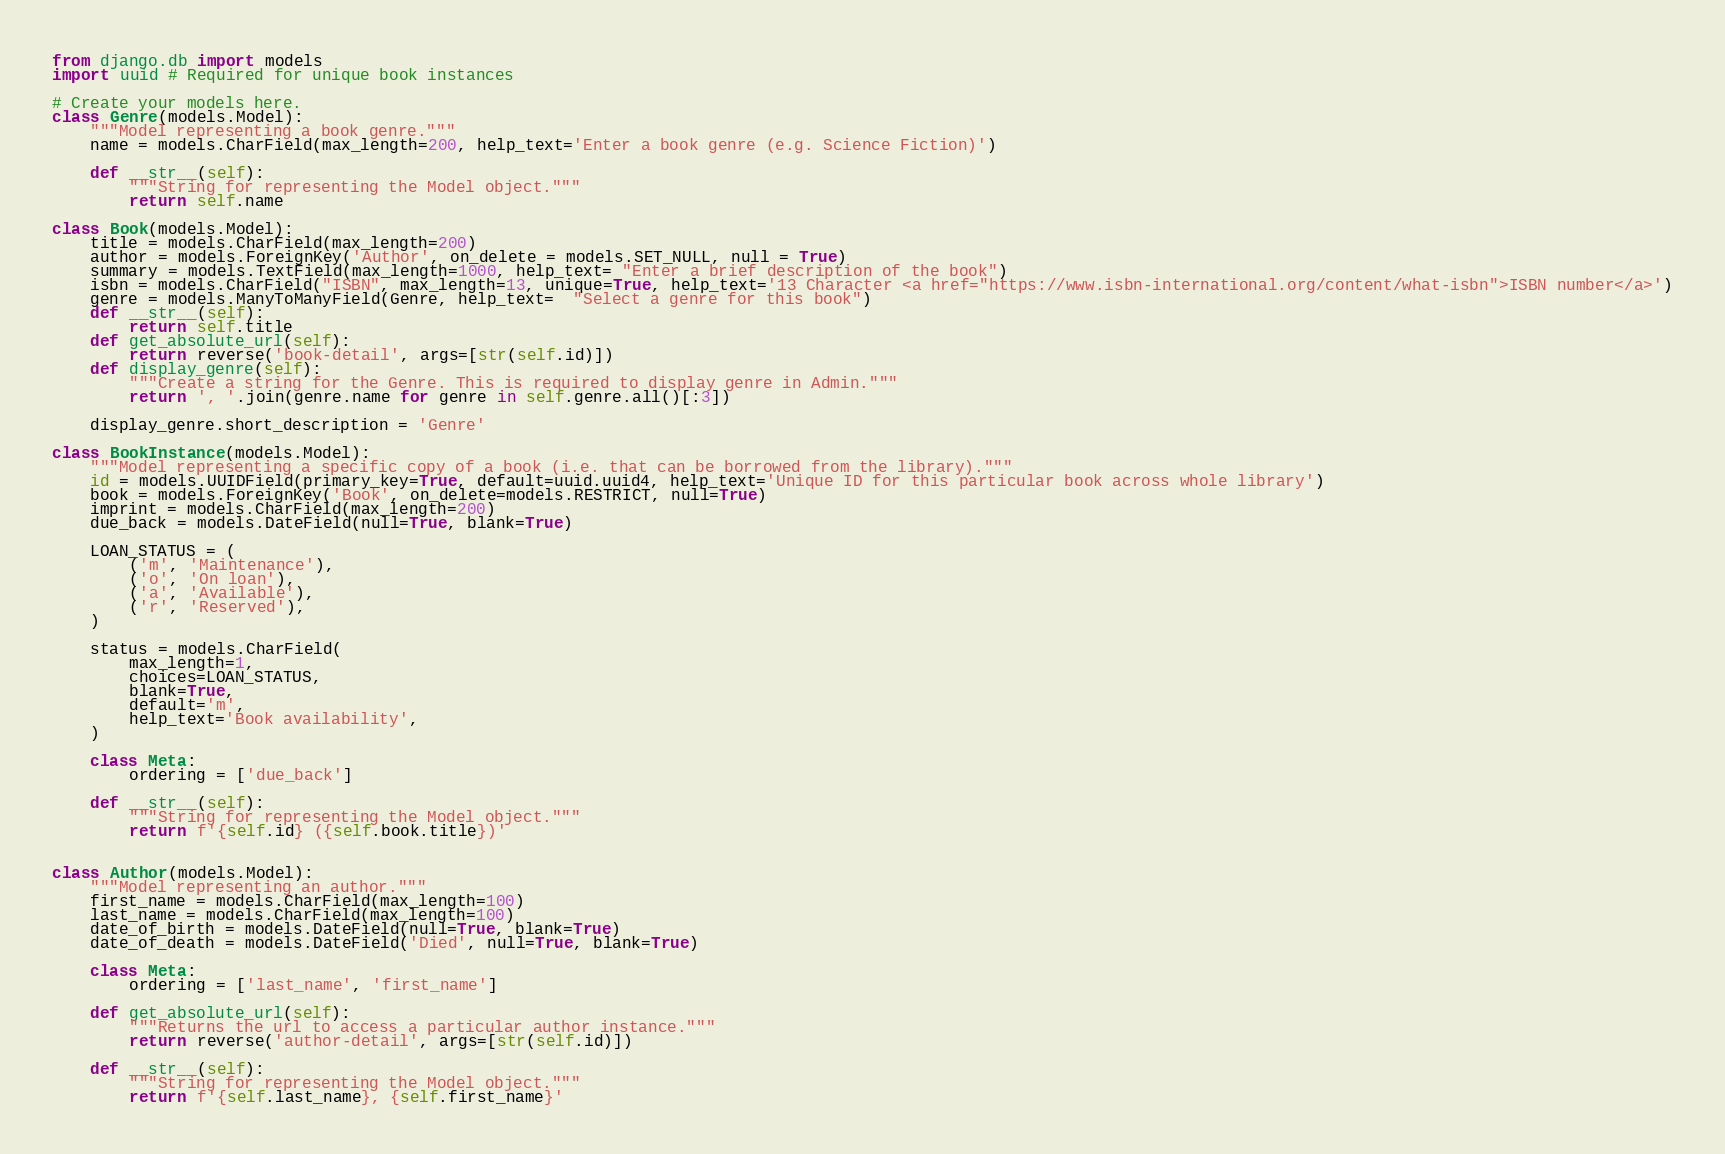<code> <loc_0><loc_0><loc_500><loc_500><_Python_>from django.db import models
import uuid # Required for unique book instances

# Create your models here.
class Genre(models.Model):
    """Model representing a book genre."""
    name = models.CharField(max_length=200, help_text='Enter a book genre (e.g. Science Fiction)')

    def __str__(self):
        """String for representing the Model object."""
        return self.name

class Book(models.Model):
    title = models.CharField(max_length=200)
    author = models.ForeignKey('Author', on_delete = models.SET_NULL, null = True)
    summary = models.TextField(max_length=1000, help_text= "Enter a brief description of the book")
    isbn = models.CharField("ISBN", max_length=13, unique=True, help_text='13 Character <a href="https://www.isbn-international.org/content/what-isbn">ISBN number</a>')
    genre = models.ManyToManyField(Genre, help_text=  "Select a genre for this book")
    def __str__(self):
        return self.title
    def get_absolute_url(self):
        return reverse('book-detail', args=[str(self.id)])
    def display_genre(self):
        """Create a string for the Genre. This is required to display genre in Admin."""
        return ', '.join(genre.name for genre in self.genre.all()[:3])

    display_genre.short_description = 'Genre'

class BookInstance(models.Model):
    """Model representing a specific copy of a book (i.e. that can be borrowed from the library)."""
    id = models.UUIDField(primary_key=True, default=uuid.uuid4, help_text='Unique ID for this particular book across whole library')
    book = models.ForeignKey('Book', on_delete=models.RESTRICT, null=True)
    imprint = models.CharField(max_length=200)
    due_back = models.DateField(null=True, blank=True)

    LOAN_STATUS = (
        ('m', 'Maintenance'),
        ('o', 'On loan'),
        ('a', 'Available'),
        ('r', 'Reserved'),
    )

    status = models.CharField(
        max_length=1,
        choices=LOAN_STATUS,
        blank=True,
        default='m',
        help_text='Book availability',
    )

    class Meta:
        ordering = ['due_back']

    def __str__(self):
        """String for representing the Model object."""
        return f'{self.id} ({self.book.title})'


class Author(models.Model):
    """Model representing an author."""
    first_name = models.CharField(max_length=100)
    last_name = models.CharField(max_length=100)
    date_of_birth = models.DateField(null=True, blank=True)
    date_of_death = models.DateField('Died', null=True, blank=True)

    class Meta:
        ordering = ['last_name', 'first_name']

    def get_absolute_url(self):
        """Returns the url to access a particular author instance."""
        return reverse('author-detail', args=[str(self.id)])

    def __str__(self):
        """String for representing the Model object."""
        return f'{self.last_name}, {self.first_name}'
</code> 